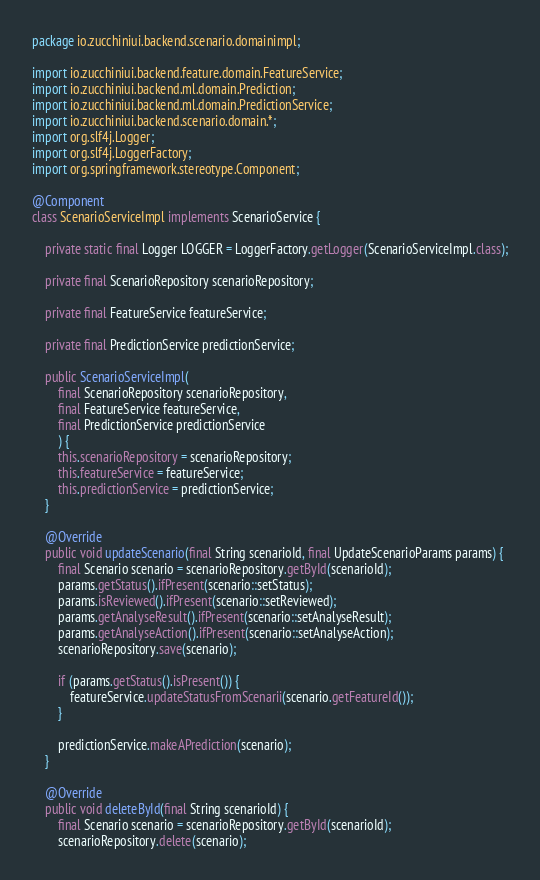Convert code to text. <code><loc_0><loc_0><loc_500><loc_500><_Java_>package io.zucchiniui.backend.scenario.domainimpl;

import io.zucchiniui.backend.feature.domain.FeatureService;
import io.zucchiniui.backend.ml.domain.Prediction;
import io.zucchiniui.backend.ml.domain.PredictionService;
import io.zucchiniui.backend.scenario.domain.*;
import org.slf4j.Logger;
import org.slf4j.LoggerFactory;
import org.springframework.stereotype.Component;

@Component
class ScenarioServiceImpl implements ScenarioService {

    private static final Logger LOGGER = LoggerFactory.getLogger(ScenarioServiceImpl.class);

    private final ScenarioRepository scenarioRepository;

    private final FeatureService featureService;

    private final PredictionService predictionService;

    public ScenarioServiceImpl(
        final ScenarioRepository scenarioRepository,
        final FeatureService featureService,
        final PredictionService predictionService
        ) {
        this.scenarioRepository = scenarioRepository;
        this.featureService = featureService;
        this.predictionService = predictionService;
    }

    @Override
    public void updateScenario(final String scenarioId, final UpdateScenarioParams params) {
        final Scenario scenario = scenarioRepository.getById(scenarioId);
        params.getStatus().ifPresent(scenario::setStatus);
        params.isReviewed().ifPresent(scenario::setReviewed);
        params.getAnalyseResult().ifPresent(scenario::setAnalyseResult);
        params.getAnalyseAction().ifPresent(scenario::setAnalyseAction);
        scenarioRepository.save(scenario);

        if (params.getStatus().isPresent()) {
            featureService.updateStatusFromScenarii(scenario.getFeatureId());
        }

        predictionService.makeAPrediction(scenario);
    }

    @Override
    public void deleteById(final String scenarioId) {
        final Scenario scenario = scenarioRepository.getById(scenarioId);
        scenarioRepository.delete(scenario);
</code> 